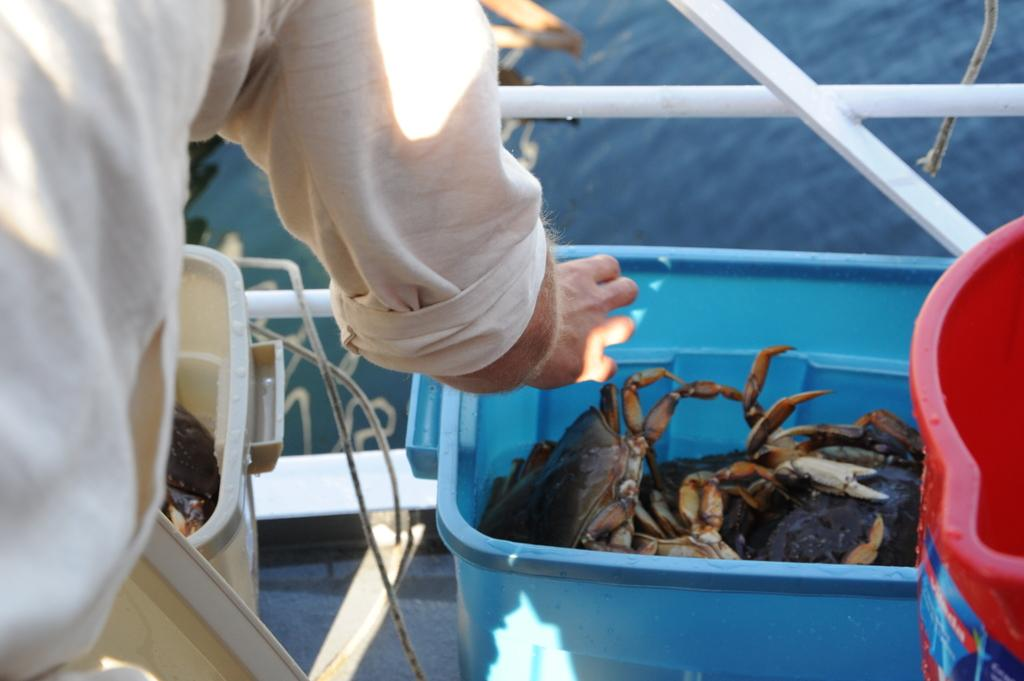What is inside the boxes in the image? There are crabs inside the boxes in the image. Can you describe the person standing in front of the boxes? There is a person standing in front of the boxes, but their appearance or actions are not specified in the facts. What can be seen in the background of the image? Water is visible in the image. What type of whip can be seen in the hands of the person in the image? There is no whip present in the image. What sound can be heard coming from the crabs in the image? The facts do not mention any sounds associated with the crabs in the image. 